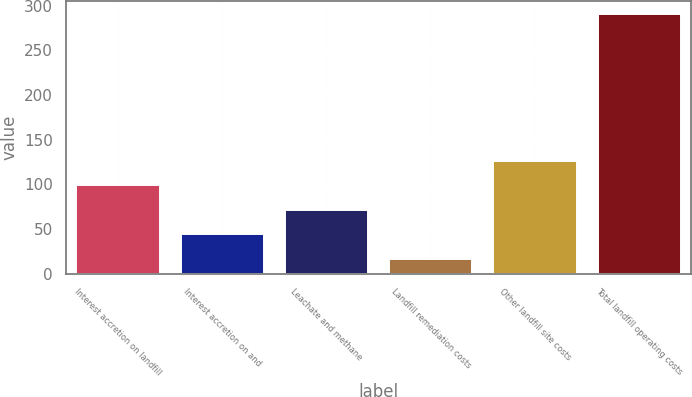Convert chart. <chart><loc_0><loc_0><loc_500><loc_500><bar_chart><fcel>Interest accretion on landfill<fcel>Interest accretion on and<fcel>Leachate and methane<fcel>Landfill remediation costs<fcel>Other landfill site costs<fcel>Total landfill operating costs<nl><fcel>99.2<fcel>44.4<fcel>71.8<fcel>17<fcel>126.6<fcel>291<nl></chart> 